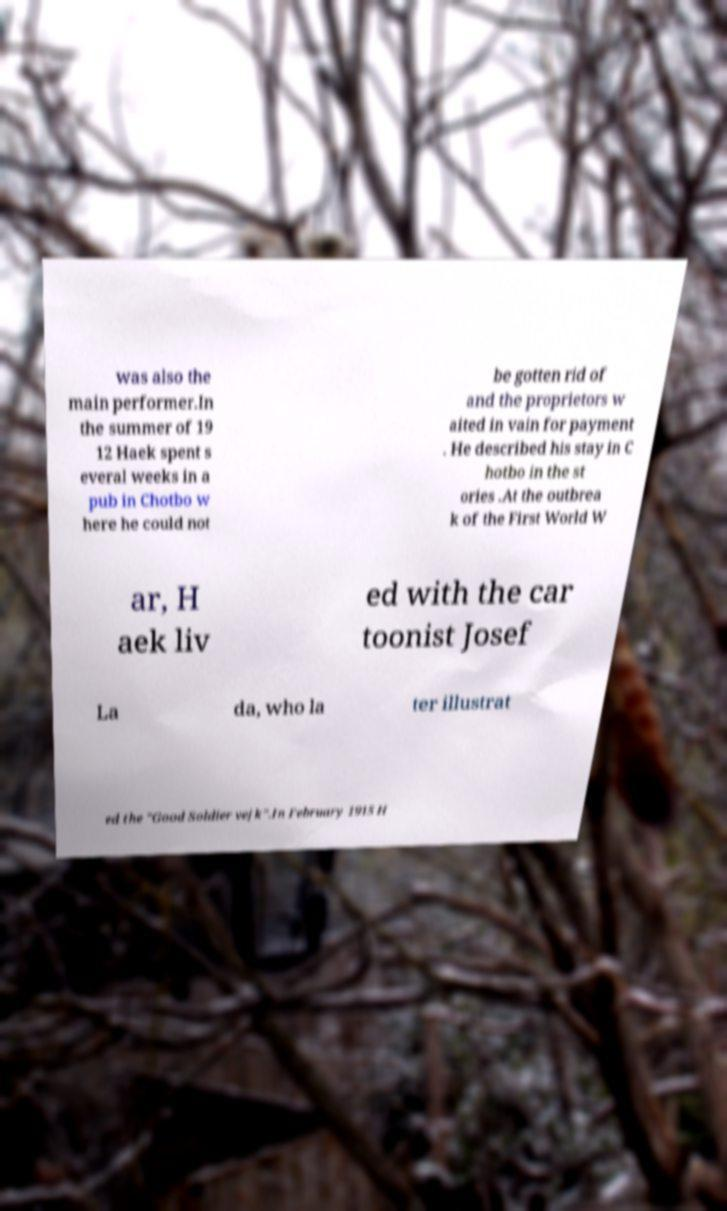Could you assist in decoding the text presented in this image and type it out clearly? was also the main performer.In the summer of 19 12 Haek spent s everal weeks in a pub in Chotbo w here he could not be gotten rid of and the proprietors w aited in vain for payment . He described his stay in C hotbo in the st ories .At the outbrea k of the First World W ar, H aek liv ed with the car toonist Josef La da, who la ter illustrat ed the "Good Soldier vejk".In February 1915 H 